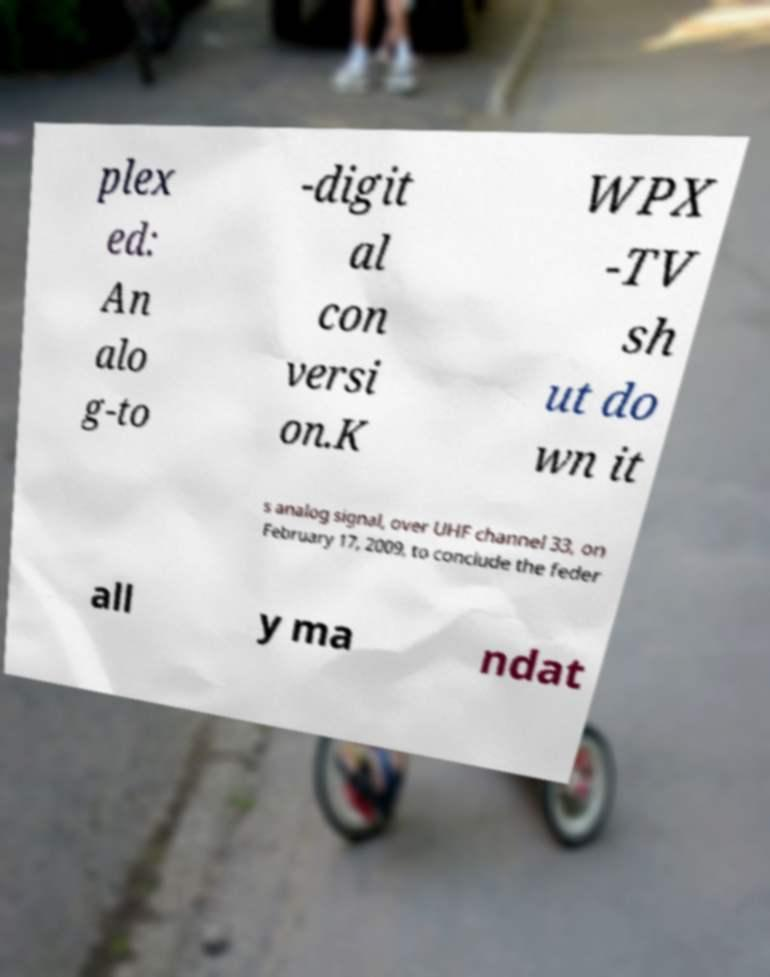Can you read and provide the text displayed in the image?This photo seems to have some interesting text. Can you extract and type it out for me? plex ed: An alo g-to -digit al con versi on.K WPX -TV sh ut do wn it s analog signal, over UHF channel 33, on February 17, 2009, to conclude the feder all y ma ndat 